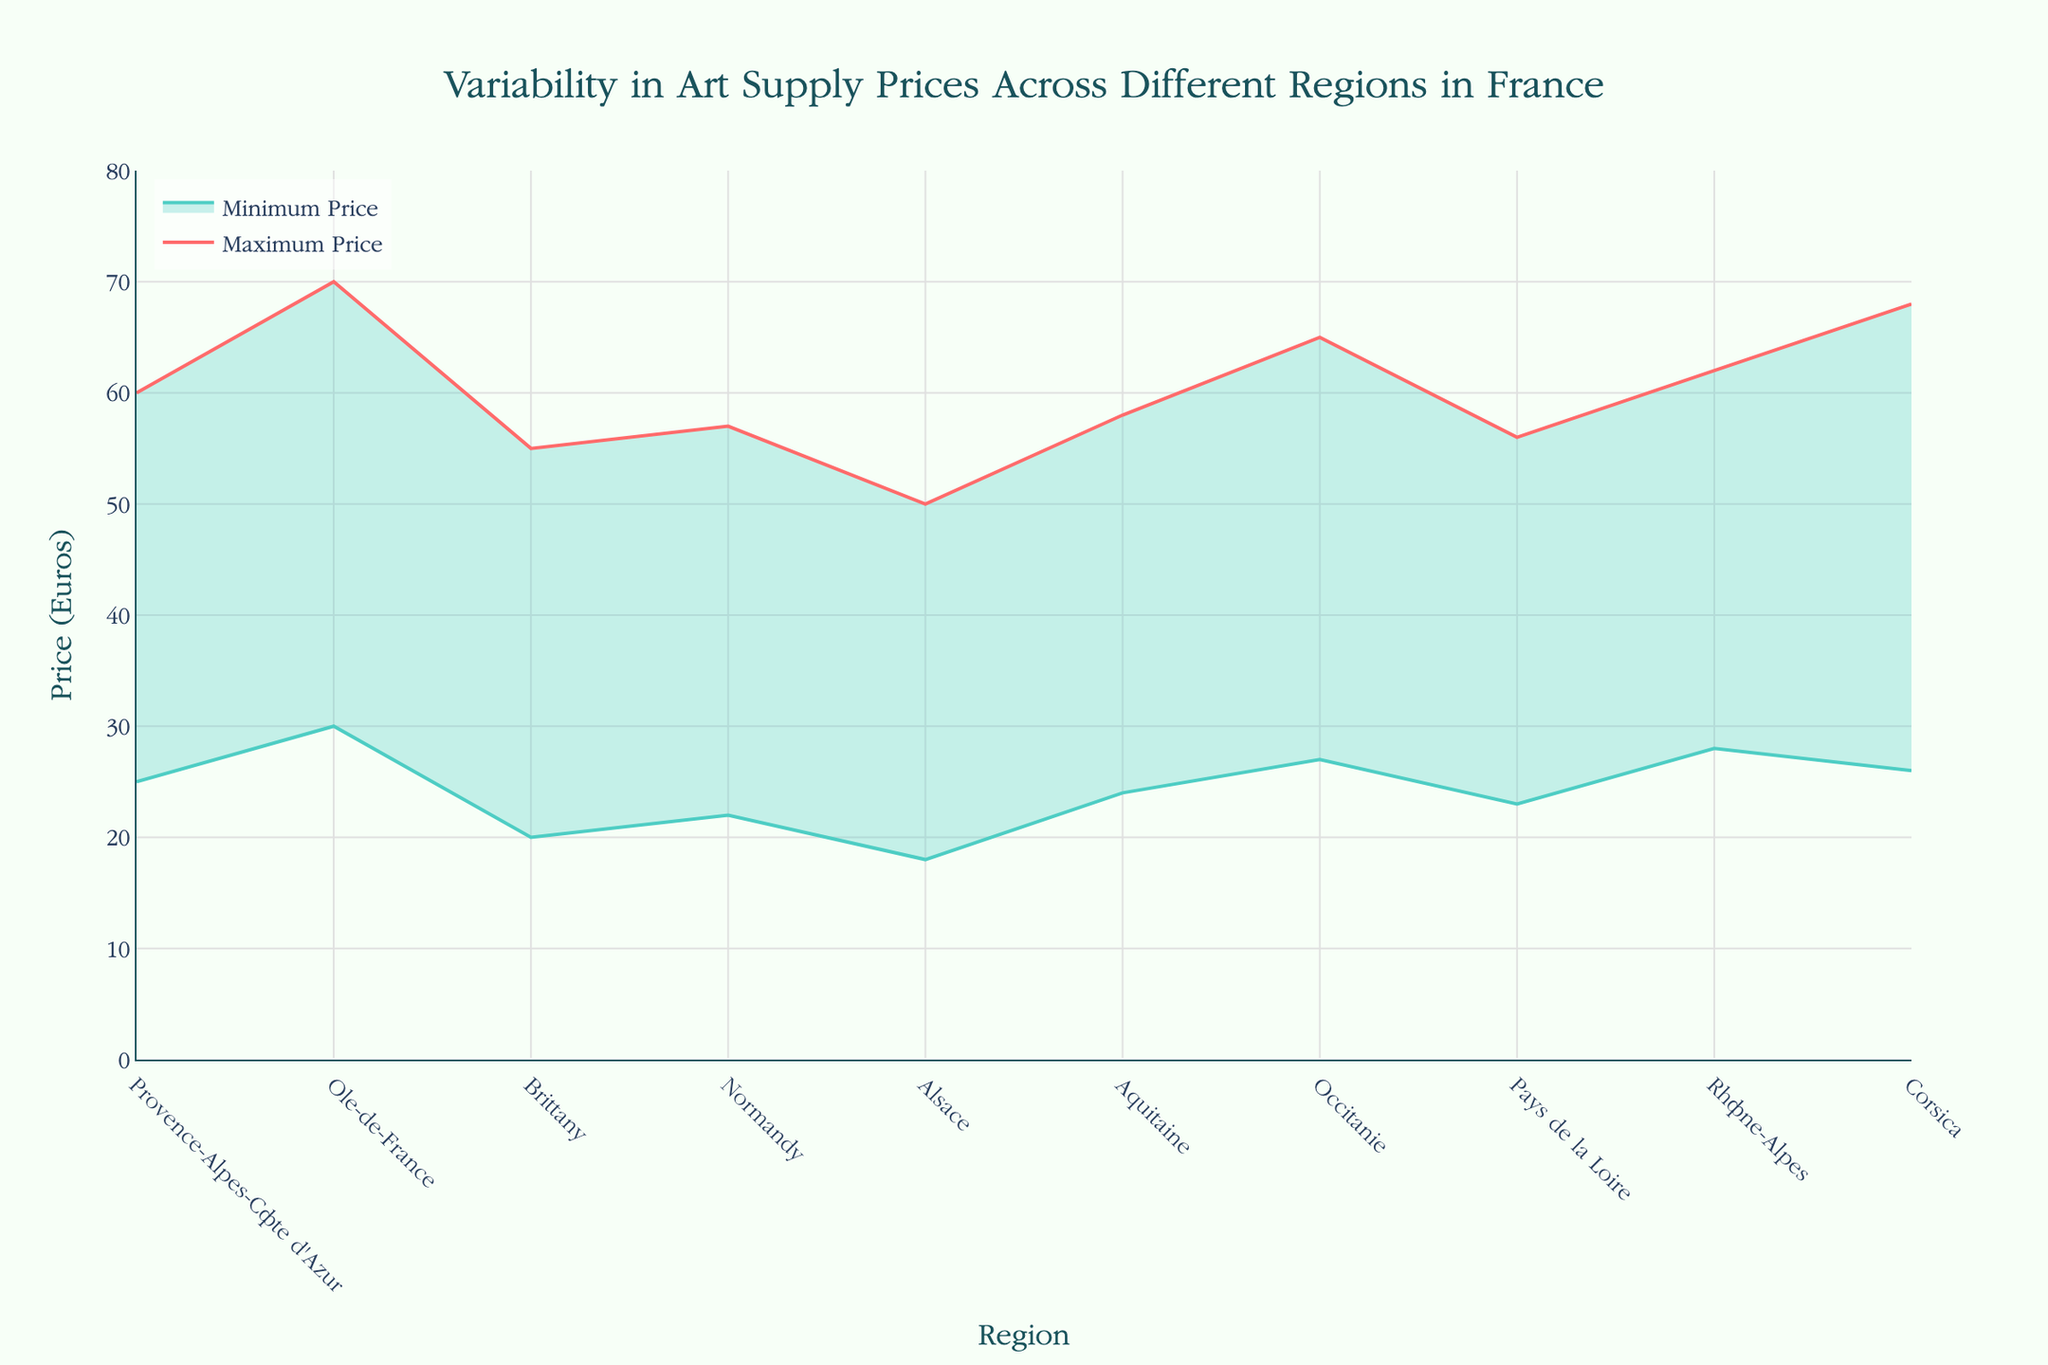Which region has the highest maximum price for art supplies? The region with the highest maximum price for art supplies can be identified by looking at the highest peak on the "Maximum Price" line. Île-de-France has the highest point at 70 Euros.
Answer: Île-de-France What is the range of art supply prices in Brittany? The range can be calculated by subtracting the minimum price from the maximum price in Brittany. The maximum price is 55 Euros, and the minimum price is 20 Euros. Thus, the range is 55 - 20 = 35 Euros.
Answer: 35 Euros Which region shows the smallest variability in art supply prices? To find the region with the smallest variability, look for the smallest difference between the maximum and minimum prices. Alsace has the minimum price of 18 Euros and the maximum price of 50 Euros, giving a range of 32 Euros, which is the smallest among the regions.
Answer: Alsace How much higher is the maximum price of art supplies in Île-de-France compared to Alsace? The maximum price in Île-de-France is 70 Euros, and in Alsace, it is 50 Euros. The difference is 70 - 50 = 20 Euros.
Answer: 20 Euros What are the average minimum and maximum prices across all regions? Calculate the average by summing up the minimum and maximum prices for all regions and dividing by the number of regions. Sum of minimum prices: 25+30+20+22+18+24+27+23+28+26 = 243. Sum of maximum prices: 60+70+55+57+50+58+65+56+62+68 = 601. Number of regions: 10. Average minimum price: 243 / 10 = 24.3 Euros. Average maximum price: 601 / 10 = 60.1 Euros.
Answer: 24.3 Euros, 60.1 Euros Which region has a maximum price most similar to the maximum price in Corsica? Check the regions' maximum prices; Rhône-Alpes has a maximum price of 62 Euros, which is closest to Corsica's maximum price of 68 Euros.
Answer: Rhône-Alpes What is the median maximum price for these regions? Arrange the maximum prices in ascending order: 50, 55, 56, 57, 58, 60, 62, 65, 68, 70. With 10 values, the median is the average of the 5th and 6th values: (58 + 60) / 2 = 59 Euros.
Answer: 59 Euros Compare the art supply price ranges in Normandy and Aquitaine. Which one has a greater range? Normandy's range is 57 - 22 = 35 Euros, and Aquitaine's range is 58 - 24 = 34 Euros. Normandy has a greater range.
Answer: Normandy In which region does the minimum price fall below 20 Euros? Review the minimum prices and find that Alsace is the only region where the minimum price (18 Euros) is below 20 Euros.
Answer: Alsace 